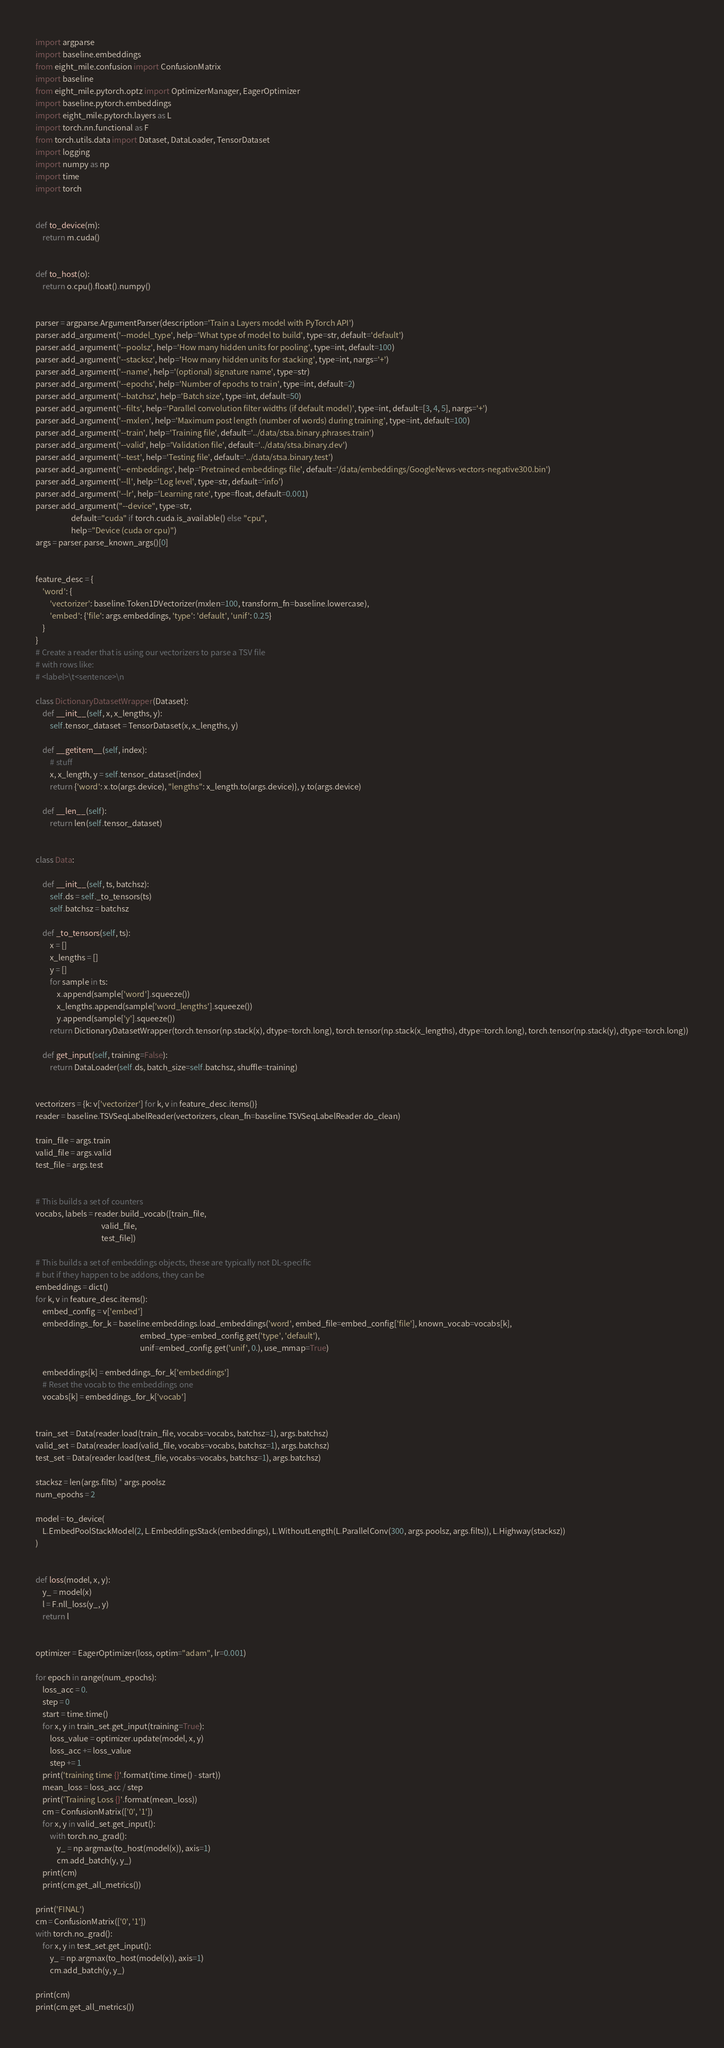Convert code to text. <code><loc_0><loc_0><loc_500><loc_500><_Python_>import argparse
import baseline.embeddings
from eight_mile.confusion import ConfusionMatrix
import baseline
from eight_mile.pytorch.optz import OptimizerManager, EagerOptimizer
import baseline.pytorch.embeddings
import eight_mile.pytorch.layers as L
import torch.nn.functional as F
from torch.utils.data import Dataset, DataLoader, TensorDataset
import logging
import numpy as np
import time
import torch


def to_device(m):
    return m.cuda()


def to_host(o):
    return o.cpu().float().numpy()


parser = argparse.ArgumentParser(description='Train a Layers model with PyTorch API')
parser.add_argument('--model_type', help='What type of model to build', type=str, default='default')
parser.add_argument('--poolsz', help='How many hidden units for pooling', type=int, default=100)
parser.add_argument('--stacksz', help='How many hidden units for stacking', type=int, nargs='+')
parser.add_argument('--name', help='(optional) signature name', type=str)
parser.add_argument('--epochs', help='Number of epochs to train', type=int, default=2)
parser.add_argument('--batchsz', help='Batch size', type=int, default=50)
parser.add_argument('--filts', help='Parallel convolution filter widths (if default model)', type=int, default=[3, 4, 5], nargs='+')
parser.add_argument('--mxlen', help='Maximum post length (number of words) during training', type=int, default=100)
parser.add_argument('--train', help='Training file', default='../data/stsa.binary.phrases.train')
parser.add_argument('--valid', help='Validation file', default='../data/stsa.binary.dev')
parser.add_argument('--test', help='Testing file', default='../data/stsa.binary.test')
parser.add_argument('--embeddings', help='Pretrained embeddings file', default='/data/embeddings/GoogleNews-vectors-negative300.bin')
parser.add_argument('--ll', help='Log level', type=str, default='info')
parser.add_argument('--lr', help='Learning rate', type=float, default=0.001)
parser.add_argument("--device", type=str,
                    default="cuda" if torch.cuda.is_available() else "cpu",
                    help="Device (cuda or cpu)")
args = parser.parse_known_args()[0]


feature_desc = {
    'word': {
        'vectorizer': baseline.Token1DVectorizer(mxlen=100, transform_fn=baseline.lowercase),
        'embed': {'file': args.embeddings, 'type': 'default', 'unif': 0.25}
    }
}
# Create a reader that is using our vectorizers to parse a TSV file
# with rows like:
# <label>\t<sentence>\n

class DictionaryDatasetWrapper(Dataset):
    def __init__(self, x, x_lengths, y):
        self.tensor_dataset = TensorDataset(x, x_lengths, y)

    def __getitem__(self, index):
        # stuff
        x, x_length, y = self.tensor_dataset[index]
        return {'word': x.to(args.device), "lengths": x_length.to(args.device)}, y.to(args.device)

    def __len__(self):
        return len(self.tensor_dataset)


class Data:

    def __init__(self, ts, batchsz):
        self.ds = self._to_tensors(ts)
        self.batchsz = batchsz

    def _to_tensors(self, ts):
        x = []
        x_lengths = []
        y = []
        for sample in ts:
            x.append(sample['word'].squeeze())
            x_lengths.append(sample['word_lengths'].squeeze())
            y.append(sample['y'].squeeze())
        return DictionaryDatasetWrapper(torch.tensor(np.stack(x), dtype=torch.long), torch.tensor(np.stack(x_lengths), dtype=torch.long), torch.tensor(np.stack(y), dtype=torch.long))

    def get_input(self, training=False):
        return DataLoader(self.ds, batch_size=self.batchsz, shuffle=training)


vectorizers = {k: v['vectorizer'] for k, v in feature_desc.items()}
reader = baseline.TSVSeqLabelReader(vectorizers, clean_fn=baseline.TSVSeqLabelReader.do_clean)

train_file = args.train
valid_file = args.valid
test_file = args.test


# This builds a set of counters
vocabs, labels = reader.build_vocab([train_file,
                                     valid_file,
                                     test_file])

# This builds a set of embeddings objects, these are typically not DL-specific
# but if they happen to be addons, they can be
embeddings = dict()
for k, v in feature_desc.items():
    embed_config = v['embed']
    embeddings_for_k = baseline.embeddings.load_embeddings('word', embed_file=embed_config['file'], known_vocab=vocabs[k],
                                                           embed_type=embed_config.get('type', 'default'),
                                                           unif=embed_config.get('unif', 0.), use_mmap=True)

    embeddings[k] = embeddings_for_k['embeddings']
    # Reset the vocab to the embeddings one
    vocabs[k] = embeddings_for_k['vocab']


train_set = Data(reader.load(train_file, vocabs=vocabs, batchsz=1), args.batchsz)
valid_set = Data(reader.load(valid_file, vocabs=vocabs, batchsz=1), args.batchsz)
test_set = Data(reader.load(test_file, vocabs=vocabs, batchsz=1), args.batchsz)

stacksz = len(args.filts) * args.poolsz
num_epochs = 2

model = to_device(
    L.EmbedPoolStackModel(2, L.EmbeddingsStack(embeddings), L.WithoutLength(L.ParallelConv(300, args.poolsz, args.filts)), L.Highway(stacksz))
)


def loss(model, x, y):
    y_ = model(x)
    l = F.nll_loss(y_, y)
    return l


optimizer = EagerOptimizer(loss, optim="adam", lr=0.001)

for epoch in range(num_epochs):
    loss_acc = 0.
    step = 0
    start = time.time()
    for x, y in train_set.get_input(training=True):
        loss_value = optimizer.update(model, x, y)
        loss_acc += loss_value
        step += 1
    print('training time {}'.format(time.time() - start))
    mean_loss = loss_acc / step
    print('Training Loss {}'.format(mean_loss))
    cm = ConfusionMatrix(['0', '1'])
    for x, y in valid_set.get_input():
        with torch.no_grad():
            y_ = np.argmax(to_host(model(x)), axis=1)
            cm.add_batch(y, y_)
    print(cm)
    print(cm.get_all_metrics())

print('FINAL')
cm = ConfusionMatrix(['0', '1'])
with torch.no_grad():
    for x, y in test_set.get_input():
        y_ = np.argmax(to_host(model(x)), axis=1)
        cm.add_batch(y, y_)

print(cm)
print(cm.get_all_metrics())
</code> 